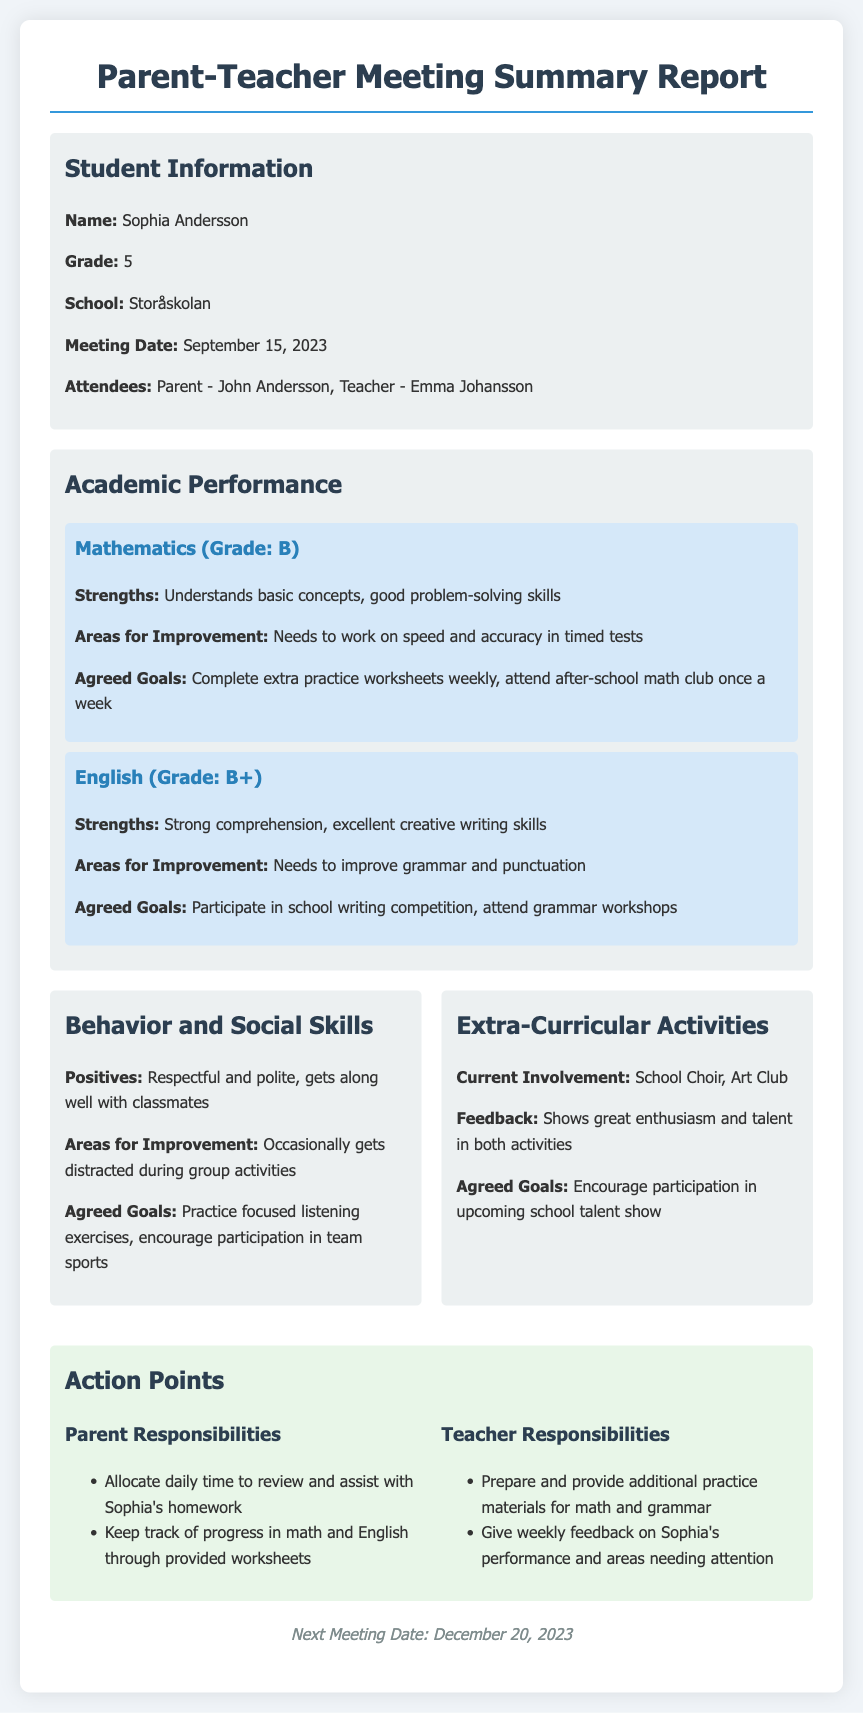what is the student's name? The student's name is mentioned in the "Student Information" section of the document.
Answer: Sophia Andersson what is the meeting date? The meeting date is specified in the "Student Information" section.
Answer: September 15, 2023 what grade is Sophia in? Sophia's grade is listed under the "Student Information" section.
Answer: 5 what are Sophia's strengths in English? Sophia's strengths in English are detailed in the "Academic Performance" section.
Answer: Strong comprehension, excellent creative writing skills what is one area for improvement in mathematics? The areas for improvement in mathematics are outlined in the "Academic Performance" section.
Answer: Needs to work on speed and accuracy in timed tests what goals were agreed upon for English? The agreed goals for English are noted in the "Academic Performance" section.
Answer: Participate in school writing competition, attend grammar workshops what are two parent responsibilities? The parent responsibilities are listed in the "Action Points" section.
Answer: Allocate daily time to review and assist with Sophia's homework; Keep track of progress in math and English through provided worksheets what is the feedback for Sophia's involvement in extra-curricular activities? The feedback for extra-curricular activities is provided in the "Extra-Curricular Activities" section.
Answer: Shows great enthusiasm and talent in both activities what is one goal for behavior and social skills? The agreed goals for behavior and social skills are found in the "Behavior and Social Skills" section.
Answer: Practice focused listening exercises what is the next meeting date? The next meeting date is indicated at the bottom of the document in the footer.
Answer: December 20, 2023 